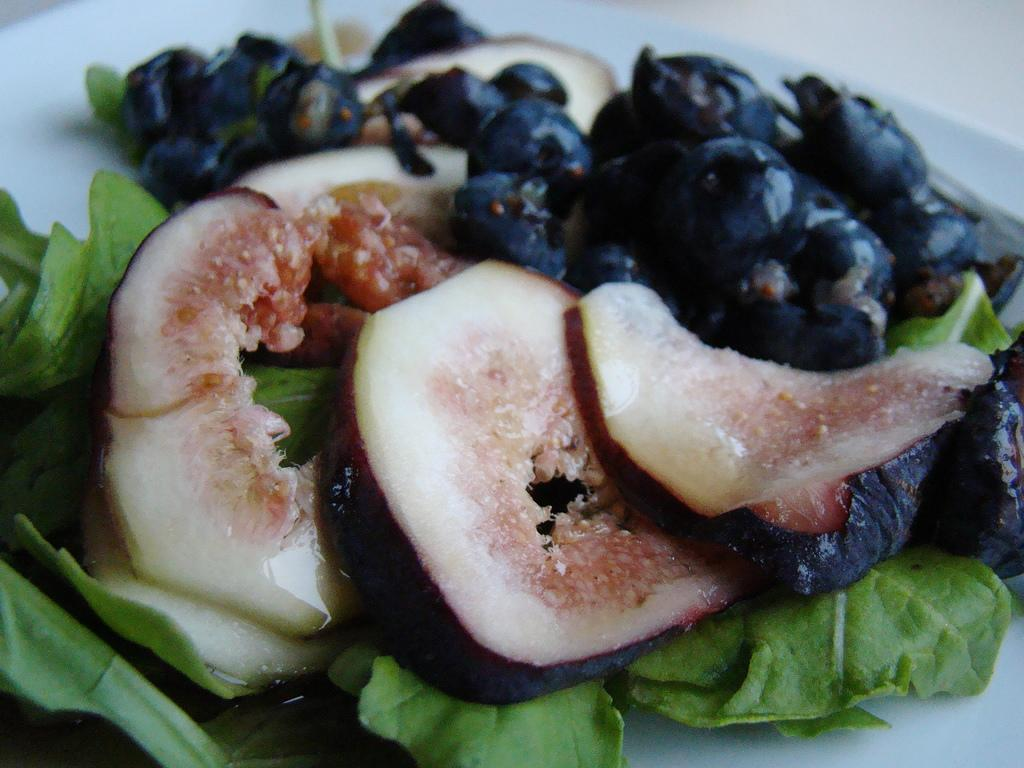What is placed on the plate in the image? There are eatables placed in a plate in the image. What type of wealth is depicted in the image? There is no depiction of wealth in the image; it only shows eatables placed in a plate. What type of border can be seen around the plate in the image? There is no border visible around the plate in the image. How many legs does the plate have in the image? The number of legs on the plate cannot be determined from the image, as the plate is not shown from a perspective that would allow us to see its base. 